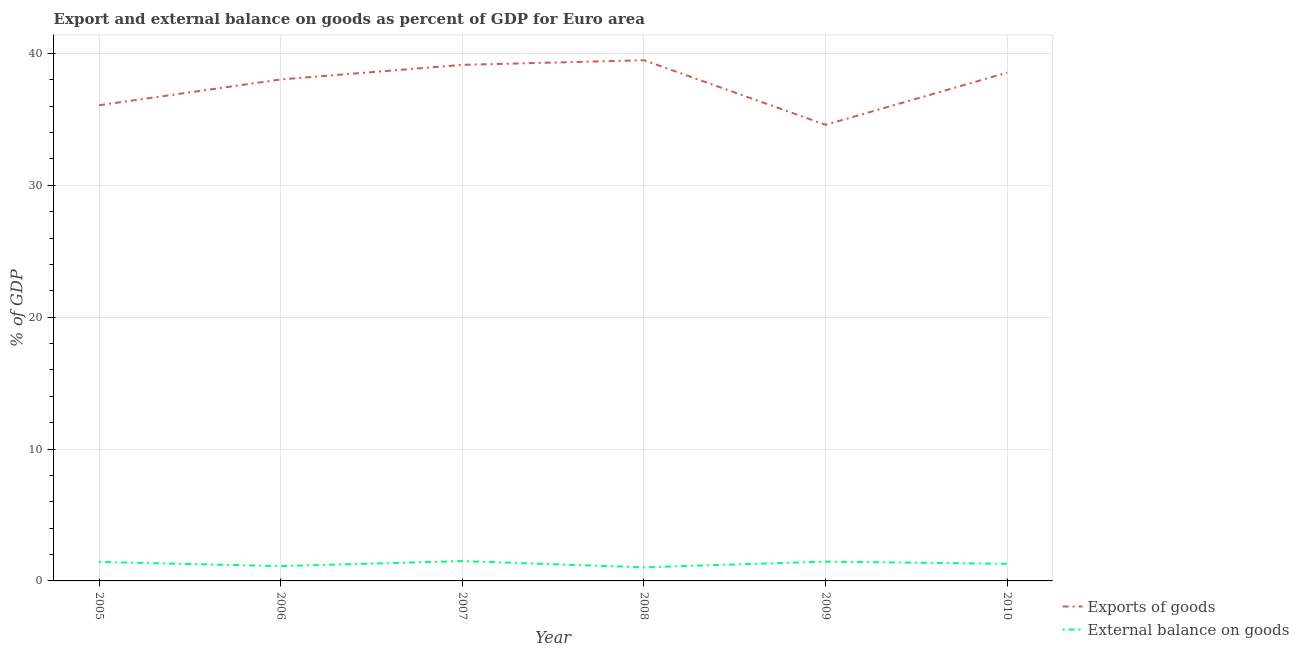Is the number of lines equal to the number of legend labels?
Offer a terse response. Yes. What is the external balance on goods as percentage of gdp in 2010?
Your response must be concise. 1.3. Across all years, what is the maximum external balance on goods as percentage of gdp?
Offer a very short reply. 1.5. Across all years, what is the minimum export of goods as percentage of gdp?
Offer a very short reply. 34.59. In which year was the export of goods as percentage of gdp minimum?
Ensure brevity in your answer.  2009. What is the total export of goods as percentage of gdp in the graph?
Ensure brevity in your answer.  225.85. What is the difference between the export of goods as percentage of gdp in 2005 and that in 2006?
Give a very brief answer. -1.96. What is the difference between the export of goods as percentage of gdp in 2006 and the external balance on goods as percentage of gdp in 2007?
Your response must be concise. 36.52. What is the average external balance on goods as percentage of gdp per year?
Give a very brief answer. 1.31. In the year 2010, what is the difference between the external balance on goods as percentage of gdp and export of goods as percentage of gdp?
Provide a short and direct response. -37.24. What is the ratio of the external balance on goods as percentage of gdp in 2006 to that in 2009?
Offer a terse response. 0.77. What is the difference between the highest and the second highest export of goods as percentage of gdp?
Keep it short and to the point. 0.35. What is the difference between the highest and the lowest export of goods as percentage of gdp?
Offer a very short reply. 4.89. Is the sum of the external balance on goods as percentage of gdp in 2008 and 2010 greater than the maximum export of goods as percentage of gdp across all years?
Your answer should be compact. No. Does the external balance on goods as percentage of gdp monotonically increase over the years?
Your answer should be very brief. No. Is the external balance on goods as percentage of gdp strictly less than the export of goods as percentage of gdp over the years?
Keep it short and to the point. Yes. How many lines are there?
Your answer should be very brief. 2. How many legend labels are there?
Your response must be concise. 2. How are the legend labels stacked?
Give a very brief answer. Vertical. What is the title of the graph?
Give a very brief answer. Export and external balance on goods as percent of GDP for Euro area. What is the label or title of the Y-axis?
Provide a succinct answer. % of GDP. What is the % of GDP of Exports of goods in 2005?
Keep it short and to the point. 36.07. What is the % of GDP of External balance on goods in 2005?
Provide a short and direct response. 1.44. What is the % of GDP in Exports of goods in 2006?
Your answer should be compact. 38.03. What is the % of GDP of External balance on goods in 2006?
Provide a succinct answer. 1.12. What is the % of GDP in Exports of goods in 2007?
Provide a succinct answer. 39.13. What is the % of GDP of External balance on goods in 2007?
Your answer should be very brief. 1.5. What is the % of GDP of Exports of goods in 2008?
Your answer should be very brief. 39.48. What is the % of GDP in External balance on goods in 2008?
Ensure brevity in your answer.  1.03. What is the % of GDP in Exports of goods in 2009?
Make the answer very short. 34.59. What is the % of GDP of External balance on goods in 2009?
Your answer should be very brief. 1.46. What is the % of GDP of Exports of goods in 2010?
Offer a very short reply. 38.54. What is the % of GDP in External balance on goods in 2010?
Provide a succinct answer. 1.3. Across all years, what is the maximum % of GDP of Exports of goods?
Your answer should be very brief. 39.48. Across all years, what is the maximum % of GDP of External balance on goods?
Your answer should be compact. 1.5. Across all years, what is the minimum % of GDP of Exports of goods?
Make the answer very short. 34.59. Across all years, what is the minimum % of GDP in External balance on goods?
Ensure brevity in your answer.  1.03. What is the total % of GDP in Exports of goods in the graph?
Your response must be concise. 225.85. What is the total % of GDP of External balance on goods in the graph?
Give a very brief answer. 7.86. What is the difference between the % of GDP in Exports of goods in 2005 and that in 2006?
Make the answer very short. -1.96. What is the difference between the % of GDP of External balance on goods in 2005 and that in 2006?
Make the answer very short. 0.32. What is the difference between the % of GDP of Exports of goods in 2005 and that in 2007?
Make the answer very short. -3.06. What is the difference between the % of GDP in External balance on goods in 2005 and that in 2007?
Your answer should be compact. -0.06. What is the difference between the % of GDP of Exports of goods in 2005 and that in 2008?
Your answer should be very brief. -3.41. What is the difference between the % of GDP of External balance on goods in 2005 and that in 2008?
Offer a terse response. 0.41. What is the difference between the % of GDP of Exports of goods in 2005 and that in 2009?
Offer a terse response. 1.48. What is the difference between the % of GDP in External balance on goods in 2005 and that in 2009?
Your response must be concise. -0.03. What is the difference between the % of GDP in Exports of goods in 2005 and that in 2010?
Provide a succinct answer. -2.47. What is the difference between the % of GDP in External balance on goods in 2005 and that in 2010?
Keep it short and to the point. 0.14. What is the difference between the % of GDP in Exports of goods in 2006 and that in 2007?
Offer a terse response. -1.1. What is the difference between the % of GDP in External balance on goods in 2006 and that in 2007?
Keep it short and to the point. -0.38. What is the difference between the % of GDP of Exports of goods in 2006 and that in 2008?
Your answer should be compact. -1.46. What is the difference between the % of GDP of External balance on goods in 2006 and that in 2008?
Your answer should be compact. 0.09. What is the difference between the % of GDP in Exports of goods in 2006 and that in 2009?
Give a very brief answer. 3.44. What is the difference between the % of GDP in External balance on goods in 2006 and that in 2009?
Your answer should be compact. -0.34. What is the difference between the % of GDP of Exports of goods in 2006 and that in 2010?
Make the answer very short. -0.51. What is the difference between the % of GDP in External balance on goods in 2006 and that in 2010?
Make the answer very short. -0.18. What is the difference between the % of GDP of Exports of goods in 2007 and that in 2008?
Give a very brief answer. -0.35. What is the difference between the % of GDP in External balance on goods in 2007 and that in 2008?
Provide a succinct answer. 0.47. What is the difference between the % of GDP in Exports of goods in 2007 and that in 2009?
Make the answer very short. 4.54. What is the difference between the % of GDP in External balance on goods in 2007 and that in 2009?
Provide a succinct answer. 0.04. What is the difference between the % of GDP in Exports of goods in 2007 and that in 2010?
Your response must be concise. 0.59. What is the difference between the % of GDP of External balance on goods in 2007 and that in 2010?
Give a very brief answer. 0.2. What is the difference between the % of GDP in Exports of goods in 2008 and that in 2009?
Provide a short and direct response. 4.89. What is the difference between the % of GDP in External balance on goods in 2008 and that in 2009?
Give a very brief answer. -0.43. What is the difference between the % of GDP of Exports of goods in 2008 and that in 2010?
Offer a very short reply. 0.94. What is the difference between the % of GDP in External balance on goods in 2008 and that in 2010?
Your response must be concise. -0.27. What is the difference between the % of GDP of Exports of goods in 2009 and that in 2010?
Provide a succinct answer. -3.95. What is the difference between the % of GDP of External balance on goods in 2009 and that in 2010?
Keep it short and to the point. 0.17. What is the difference between the % of GDP of Exports of goods in 2005 and the % of GDP of External balance on goods in 2006?
Your answer should be compact. 34.95. What is the difference between the % of GDP of Exports of goods in 2005 and the % of GDP of External balance on goods in 2007?
Make the answer very short. 34.57. What is the difference between the % of GDP in Exports of goods in 2005 and the % of GDP in External balance on goods in 2008?
Ensure brevity in your answer.  35.04. What is the difference between the % of GDP of Exports of goods in 2005 and the % of GDP of External balance on goods in 2009?
Provide a short and direct response. 34.61. What is the difference between the % of GDP in Exports of goods in 2005 and the % of GDP in External balance on goods in 2010?
Your response must be concise. 34.77. What is the difference between the % of GDP in Exports of goods in 2006 and the % of GDP in External balance on goods in 2007?
Your response must be concise. 36.52. What is the difference between the % of GDP of Exports of goods in 2006 and the % of GDP of External balance on goods in 2008?
Provide a short and direct response. 37. What is the difference between the % of GDP in Exports of goods in 2006 and the % of GDP in External balance on goods in 2009?
Provide a succinct answer. 36.56. What is the difference between the % of GDP of Exports of goods in 2006 and the % of GDP of External balance on goods in 2010?
Your answer should be compact. 36.73. What is the difference between the % of GDP of Exports of goods in 2007 and the % of GDP of External balance on goods in 2008?
Keep it short and to the point. 38.1. What is the difference between the % of GDP of Exports of goods in 2007 and the % of GDP of External balance on goods in 2009?
Offer a terse response. 37.67. What is the difference between the % of GDP in Exports of goods in 2007 and the % of GDP in External balance on goods in 2010?
Provide a succinct answer. 37.83. What is the difference between the % of GDP of Exports of goods in 2008 and the % of GDP of External balance on goods in 2009?
Ensure brevity in your answer.  38.02. What is the difference between the % of GDP in Exports of goods in 2008 and the % of GDP in External balance on goods in 2010?
Offer a terse response. 38.19. What is the difference between the % of GDP of Exports of goods in 2009 and the % of GDP of External balance on goods in 2010?
Offer a terse response. 33.29. What is the average % of GDP of Exports of goods per year?
Make the answer very short. 37.64. What is the average % of GDP of External balance on goods per year?
Make the answer very short. 1.31. In the year 2005, what is the difference between the % of GDP of Exports of goods and % of GDP of External balance on goods?
Give a very brief answer. 34.63. In the year 2006, what is the difference between the % of GDP of Exports of goods and % of GDP of External balance on goods?
Your answer should be very brief. 36.9. In the year 2007, what is the difference between the % of GDP in Exports of goods and % of GDP in External balance on goods?
Offer a terse response. 37.63. In the year 2008, what is the difference between the % of GDP in Exports of goods and % of GDP in External balance on goods?
Ensure brevity in your answer.  38.45. In the year 2009, what is the difference between the % of GDP of Exports of goods and % of GDP of External balance on goods?
Your response must be concise. 33.13. In the year 2010, what is the difference between the % of GDP in Exports of goods and % of GDP in External balance on goods?
Your response must be concise. 37.24. What is the ratio of the % of GDP of Exports of goods in 2005 to that in 2006?
Your answer should be compact. 0.95. What is the ratio of the % of GDP of External balance on goods in 2005 to that in 2006?
Offer a very short reply. 1.28. What is the ratio of the % of GDP in Exports of goods in 2005 to that in 2007?
Keep it short and to the point. 0.92. What is the ratio of the % of GDP of External balance on goods in 2005 to that in 2007?
Offer a very short reply. 0.96. What is the ratio of the % of GDP of Exports of goods in 2005 to that in 2008?
Offer a terse response. 0.91. What is the ratio of the % of GDP of External balance on goods in 2005 to that in 2008?
Offer a very short reply. 1.39. What is the ratio of the % of GDP in Exports of goods in 2005 to that in 2009?
Provide a short and direct response. 1.04. What is the ratio of the % of GDP in External balance on goods in 2005 to that in 2009?
Your answer should be very brief. 0.98. What is the ratio of the % of GDP in Exports of goods in 2005 to that in 2010?
Offer a terse response. 0.94. What is the ratio of the % of GDP in External balance on goods in 2005 to that in 2010?
Offer a terse response. 1.11. What is the ratio of the % of GDP in Exports of goods in 2006 to that in 2007?
Your answer should be very brief. 0.97. What is the ratio of the % of GDP in External balance on goods in 2006 to that in 2007?
Your response must be concise. 0.75. What is the ratio of the % of GDP in Exports of goods in 2006 to that in 2008?
Your answer should be compact. 0.96. What is the ratio of the % of GDP of External balance on goods in 2006 to that in 2008?
Give a very brief answer. 1.09. What is the ratio of the % of GDP of Exports of goods in 2006 to that in 2009?
Your answer should be compact. 1.1. What is the ratio of the % of GDP in External balance on goods in 2006 to that in 2009?
Your answer should be compact. 0.77. What is the ratio of the % of GDP of Exports of goods in 2006 to that in 2010?
Make the answer very short. 0.99. What is the ratio of the % of GDP in External balance on goods in 2006 to that in 2010?
Give a very brief answer. 0.87. What is the ratio of the % of GDP in Exports of goods in 2007 to that in 2008?
Keep it short and to the point. 0.99. What is the ratio of the % of GDP of External balance on goods in 2007 to that in 2008?
Offer a terse response. 1.46. What is the ratio of the % of GDP of Exports of goods in 2007 to that in 2009?
Offer a terse response. 1.13. What is the ratio of the % of GDP in External balance on goods in 2007 to that in 2009?
Make the answer very short. 1.03. What is the ratio of the % of GDP of Exports of goods in 2007 to that in 2010?
Keep it short and to the point. 1.02. What is the ratio of the % of GDP in External balance on goods in 2007 to that in 2010?
Offer a very short reply. 1.16. What is the ratio of the % of GDP in Exports of goods in 2008 to that in 2009?
Offer a very short reply. 1.14. What is the ratio of the % of GDP of External balance on goods in 2008 to that in 2009?
Provide a short and direct response. 0.7. What is the ratio of the % of GDP of Exports of goods in 2008 to that in 2010?
Provide a short and direct response. 1.02. What is the ratio of the % of GDP in External balance on goods in 2008 to that in 2010?
Ensure brevity in your answer.  0.79. What is the ratio of the % of GDP in Exports of goods in 2009 to that in 2010?
Keep it short and to the point. 0.9. What is the ratio of the % of GDP in External balance on goods in 2009 to that in 2010?
Provide a succinct answer. 1.13. What is the difference between the highest and the second highest % of GDP of Exports of goods?
Provide a short and direct response. 0.35. What is the difference between the highest and the second highest % of GDP in External balance on goods?
Make the answer very short. 0.04. What is the difference between the highest and the lowest % of GDP of Exports of goods?
Provide a succinct answer. 4.89. What is the difference between the highest and the lowest % of GDP of External balance on goods?
Offer a terse response. 0.47. 